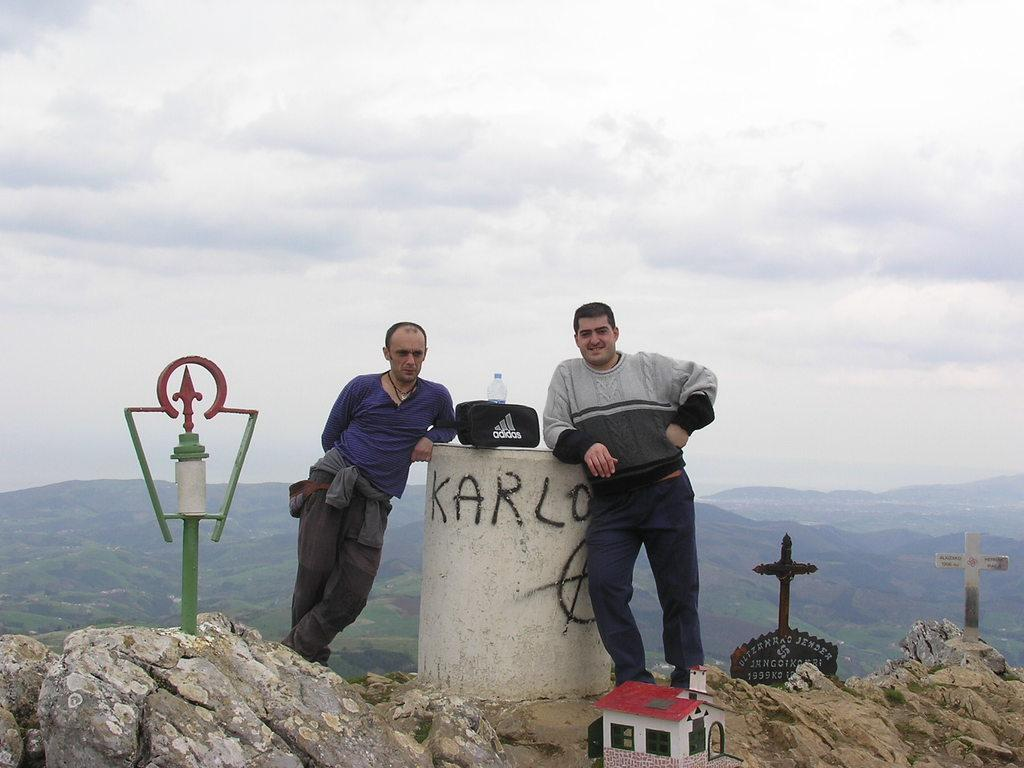What type of structure is present in the image? There is a toy house in the image. What natural elements can be seen in the image? There are rocks, hills, and trees in the image. How many people are visible in the image? Two people are standing in the front of the image. What is visible in the background of the image? There are hills and trees in the image. What can be seen in the sky in the image? The sky is visible in the image, and clouds are present. What type of alarm is going off in the image? There is no alarm present in the image. Is there a band playing in the image? There is no band present in the image. 